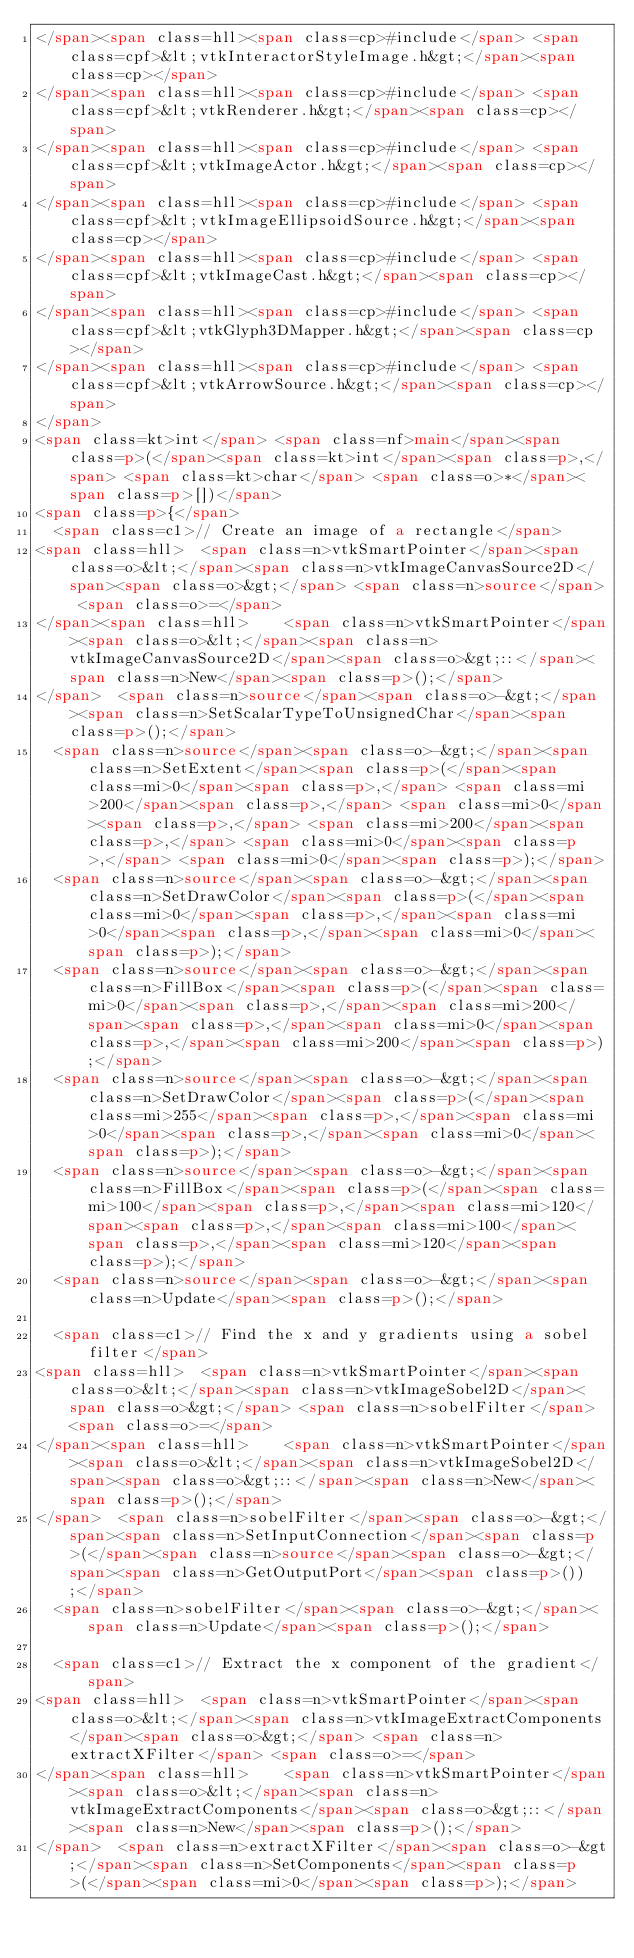Convert code to text. <code><loc_0><loc_0><loc_500><loc_500><_HTML_></span><span class=hll><span class=cp>#include</span> <span class=cpf>&lt;vtkInteractorStyleImage.h&gt;</span><span class=cp></span>
</span><span class=hll><span class=cp>#include</span> <span class=cpf>&lt;vtkRenderer.h&gt;</span><span class=cp></span>
</span><span class=hll><span class=cp>#include</span> <span class=cpf>&lt;vtkImageActor.h&gt;</span><span class=cp></span>
</span><span class=hll><span class=cp>#include</span> <span class=cpf>&lt;vtkImageEllipsoidSource.h&gt;</span><span class=cp></span>
</span><span class=hll><span class=cp>#include</span> <span class=cpf>&lt;vtkImageCast.h&gt;</span><span class=cp></span>
</span><span class=hll><span class=cp>#include</span> <span class=cpf>&lt;vtkGlyph3DMapper.h&gt;</span><span class=cp></span>
</span><span class=hll><span class=cp>#include</span> <span class=cpf>&lt;vtkArrowSource.h&gt;</span><span class=cp></span>
</span>
<span class=kt>int</span> <span class=nf>main</span><span class=p>(</span><span class=kt>int</span><span class=p>,</span> <span class=kt>char</span> <span class=o>*</span><span class=p>[])</span>
<span class=p>{</span>
  <span class=c1>// Create an image of a rectangle</span>
<span class=hll>  <span class=n>vtkSmartPointer</span><span class=o>&lt;</span><span class=n>vtkImageCanvasSource2D</span><span class=o>&gt;</span> <span class=n>source</span> <span class=o>=</span> 
</span><span class=hll>    <span class=n>vtkSmartPointer</span><span class=o>&lt;</span><span class=n>vtkImageCanvasSource2D</span><span class=o>&gt;::</span><span class=n>New</span><span class=p>();</span>
</span>  <span class=n>source</span><span class=o>-&gt;</span><span class=n>SetScalarTypeToUnsignedChar</span><span class=p>();</span>
  <span class=n>source</span><span class=o>-&gt;</span><span class=n>SetExtent</span><span class=p>(</span><span class=mi>0</span><span class=p>,</span> <span class=mi>200</span><span class=p>,</span> <span class=mi>0</span><span class=p>,</span> <span class=mi>200</span><span class=p>,</span> <span class=mi>0</span><span class=p>,</span> <span class=mi>0</span><span class=p>);</span>
  <span class=n>source</span><span class=o>-&gt;</span><span class=n>SetDrawColor</span><span class=p>(</span><span class=mi>0</span><span class=p>,</span><span class=mi>0</span><span class=p>,</span><span class=mi>0</span><span class=p>);</span>
  <span class=n>source</span><span class=o>-&gt;</span><span class=n>FillBox</span><span class=p>(</span><span class=mi>0</span><span class=p>,</span><span class=mi>200</span><span class=p>,</span><span class=mi>0</span><span class=p>,</span><span class=mi>200</span><span class=p>);</span>
  <span class=n>source</span><span class=o>-&gt;</span><span class=n>SetDrawColor</span><span class=p>(</span><span class=mi>255</span><span class=p>,</span><span class=mi>0</span><span class=p>,</span><span class=mi>0</span><span class=p>);</span>
  <span class=n>source</span><span class=o>-&gt;</span><span class=n>FillBox</span><span class=p>(</span><span class=mi>100</span><span class=p>,</span><span class=mi>120</span><span class=p>,</span><span class=mi>100</span><span class=p>,</span><span class=mi>120</span><span class=p>);</span>
  <span class=n>source</span><span class=o>-&gt;</span><span class=n>Update</span><span class=p>();</span>

  <span class=c1>// Find the x and y gradients using a sobel filter</span>
<span class=hll>  <span class=n>vtkSmartPointer</span><span class=o>&lt;</span><span class=n>vtkImageSobel2D</span><span class=o>&gt;</span> <span class=n>sobelFilter</span> <span class=o>=</span> 
</span><span class=hll>    <span class=n>vtkSmartPointer</span><span class=o>&lt;</span><span class=n>vtkImageSobel2D</span><span class=o>&gt;::</span><span class=n>New</span><span class=p>();</span>
</span>  <span class=n>sobelFilter</span><span class=o>-&gt;</span><span class=n>SetInputConnection</span><span class=p>(</span><span class=n>source</span><span class=o>-&gt;</span><span class=n>GetOutputPort</span><span class=p>());</span>
  <span class=n>sobelFilter</span><span class=o>-&gt;</span><span class=n>Update</span><span class=p>();</span>

  <span class=c1>// Extract the x component of the gradient</span>
<span class=hll>  <span class=n>vtkSmartPointer</span><span class=o>&lt;</span><span class=n>vtkImageExtractComponents</span><span class=o>&gt;</span> <span class=n>extractXFilter</span> <span class=o>=</span> 
</span><span class=hll>    <span class=n>vtkSmartPointer</span><span class=o>&lt;</span><span class=n>vtkImageExtractComponents</span><span class=o>&gt;::</span><span class=n>New</span><span class=p>();</span>
</span>  <span class=n>extractXFilter</span><span class=o>-&gt;</span><span class=n>SetComponents</span><span class=p>(</span><span class=mi>0</span><span class=p>);</span></code> 